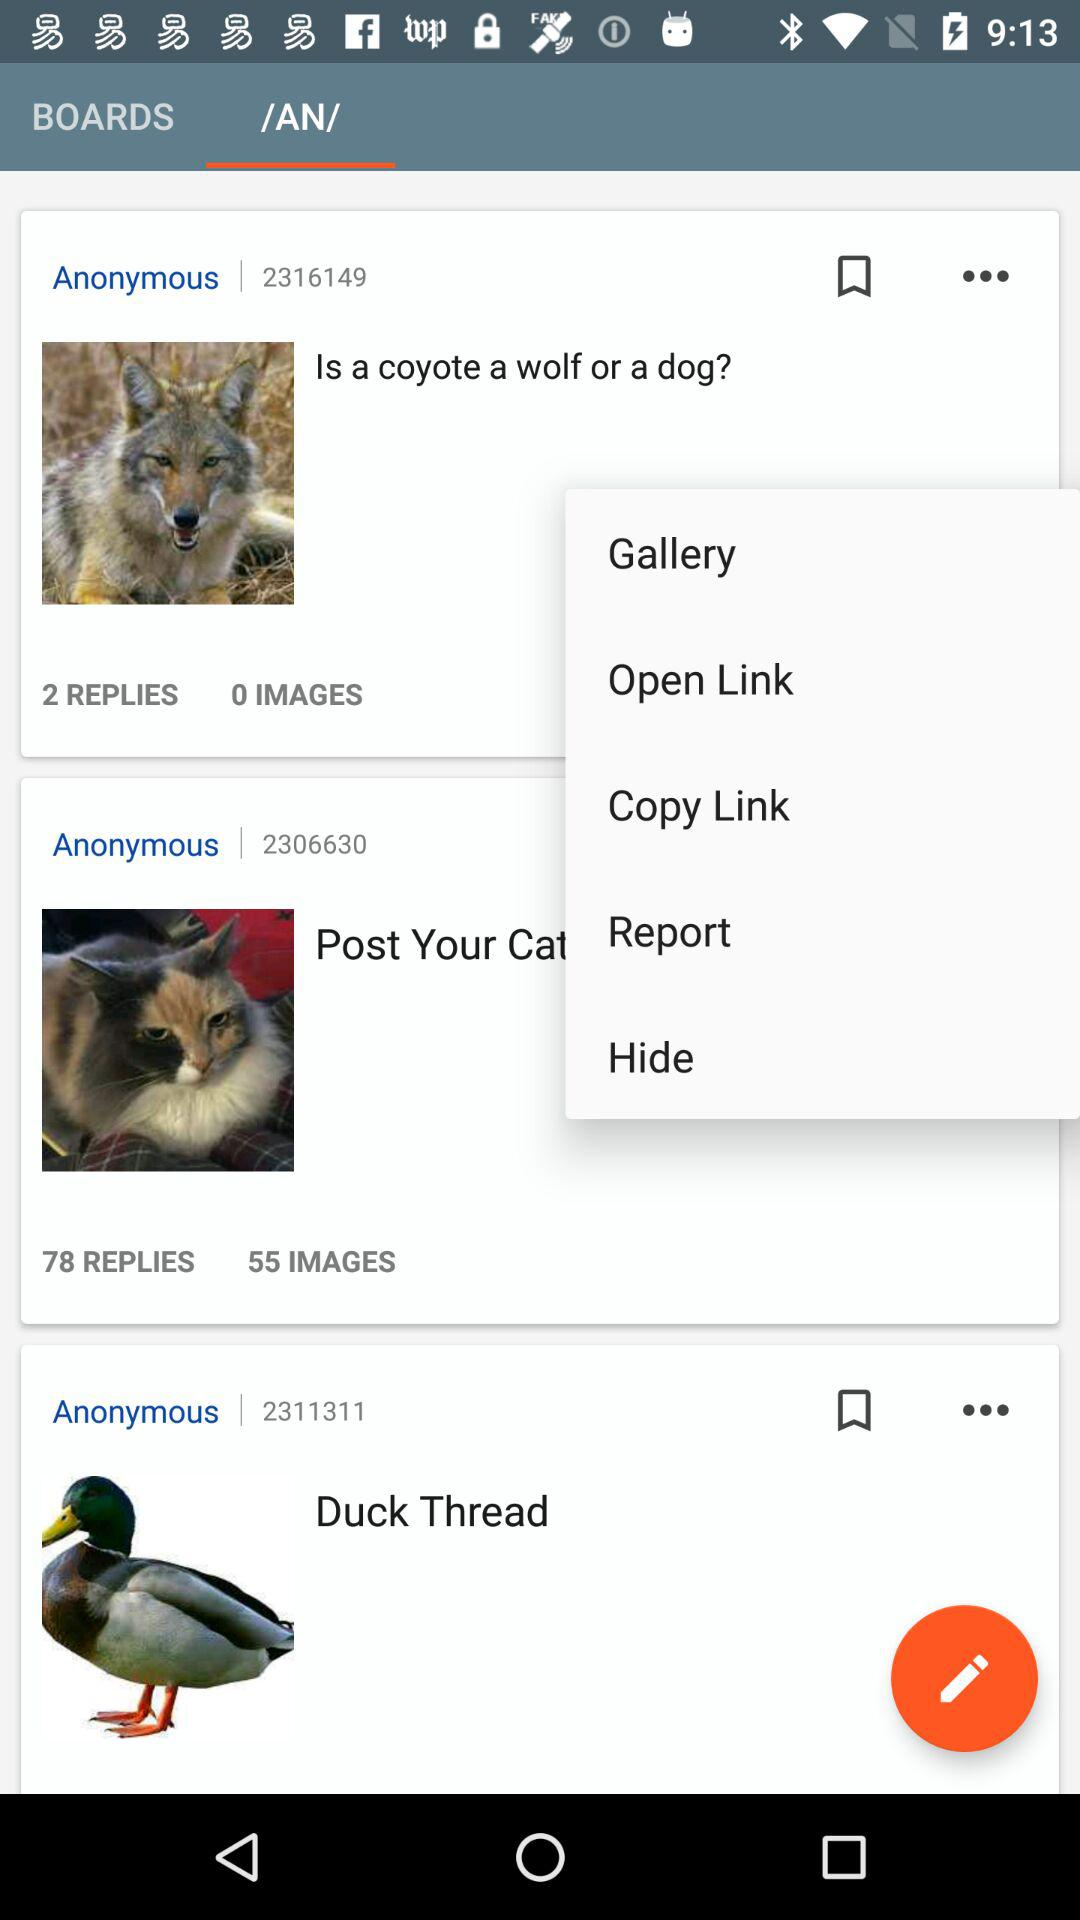Which is the selected tab? The selected tab is "/AN/". 